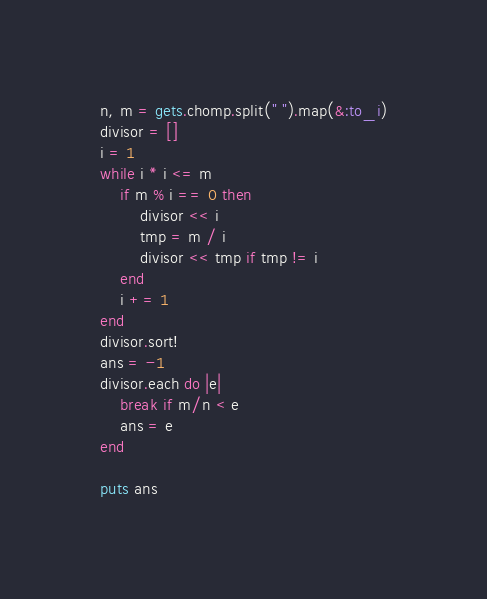<code> <loc_0><loc_0><loc_500><loc_500><_Ruby_>n, m = gets.chomp.split(" ").map(&:to_i)
divisor = []
i = 1
while i * i <= m
    if m % i == 0 then
        divisor << i
        tmp = m / i
        divisor << tmp if tmp != i
    end
    i += 1
end
divisor.sort!
ans = -1
divisor.each do |e|
    break if m/n < e
    ans = e
end

puts ans</code> 